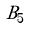Convert formula to latex. <formula><loc_0><loc_0><loc_500><loc_500>\tilde { B } _ { 5 }</formula> 